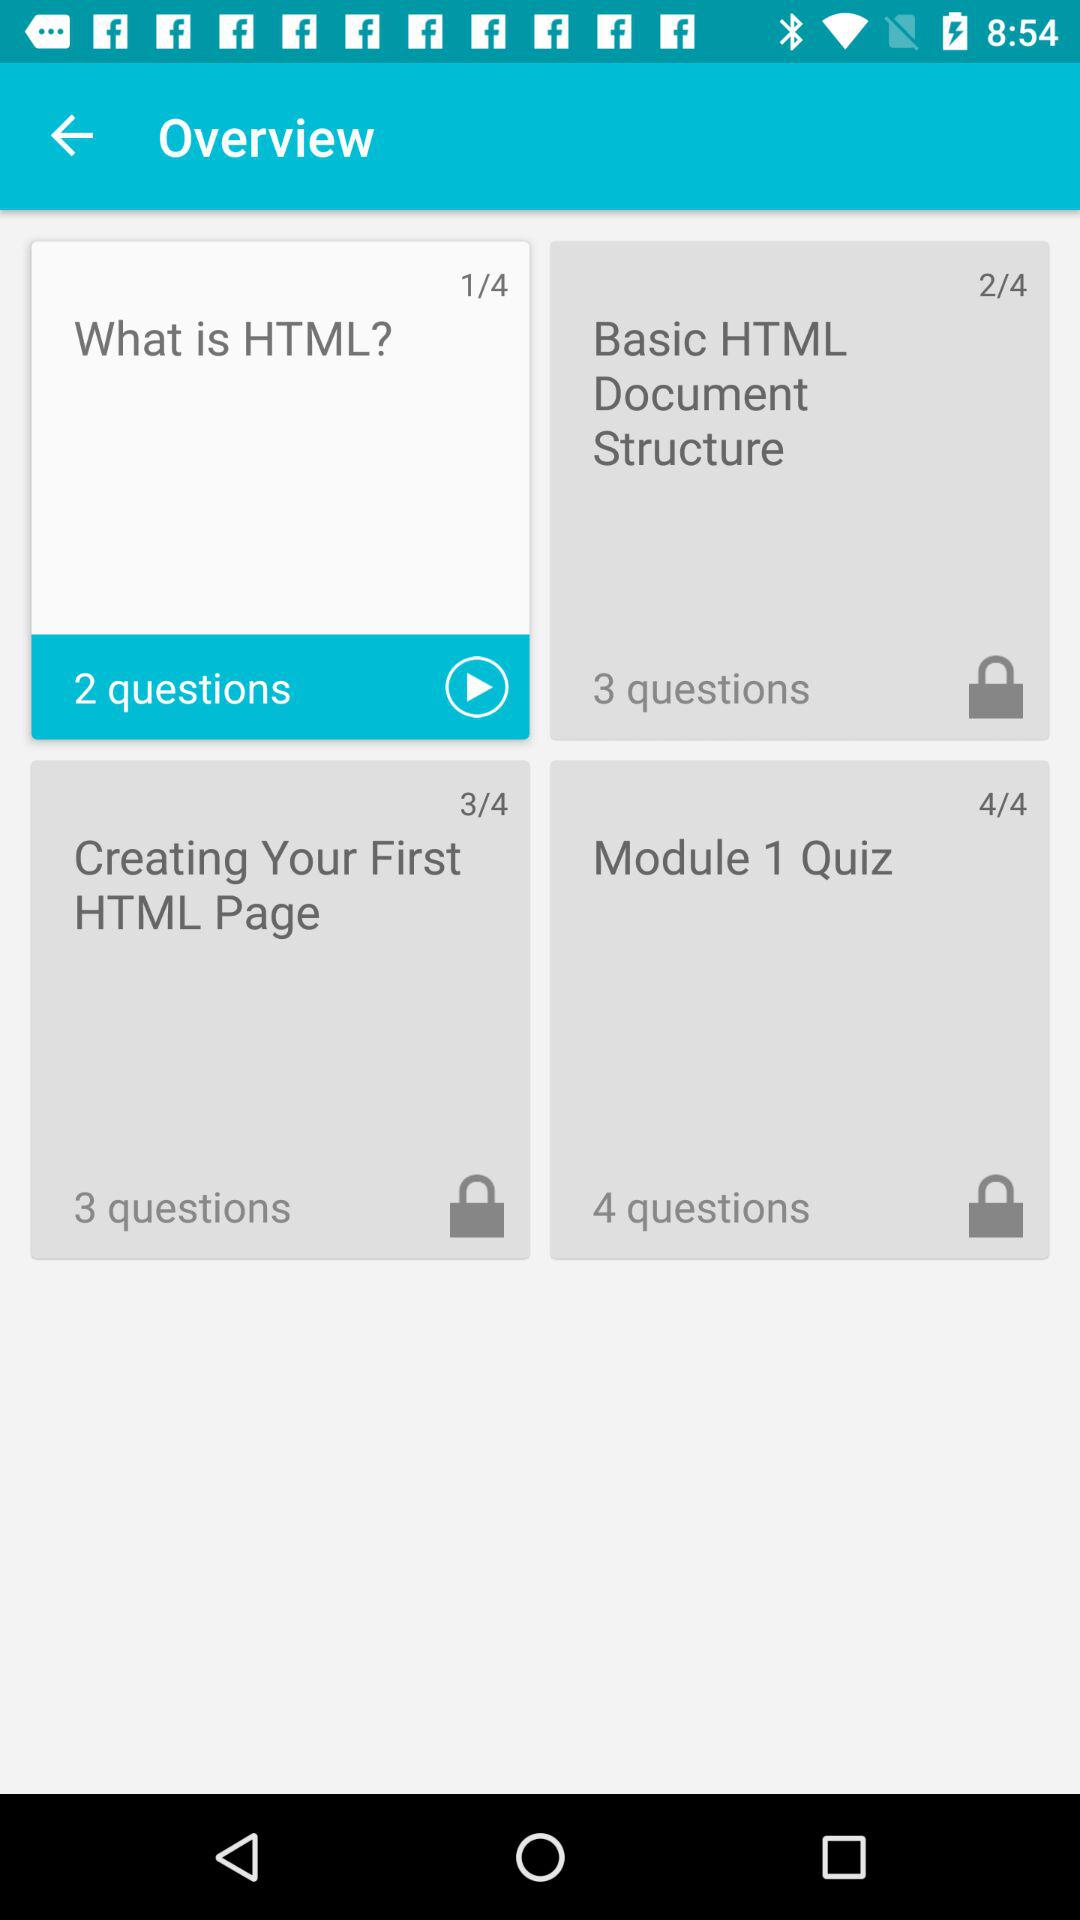Which course is being played? The course "What is HTML?" is being played. 